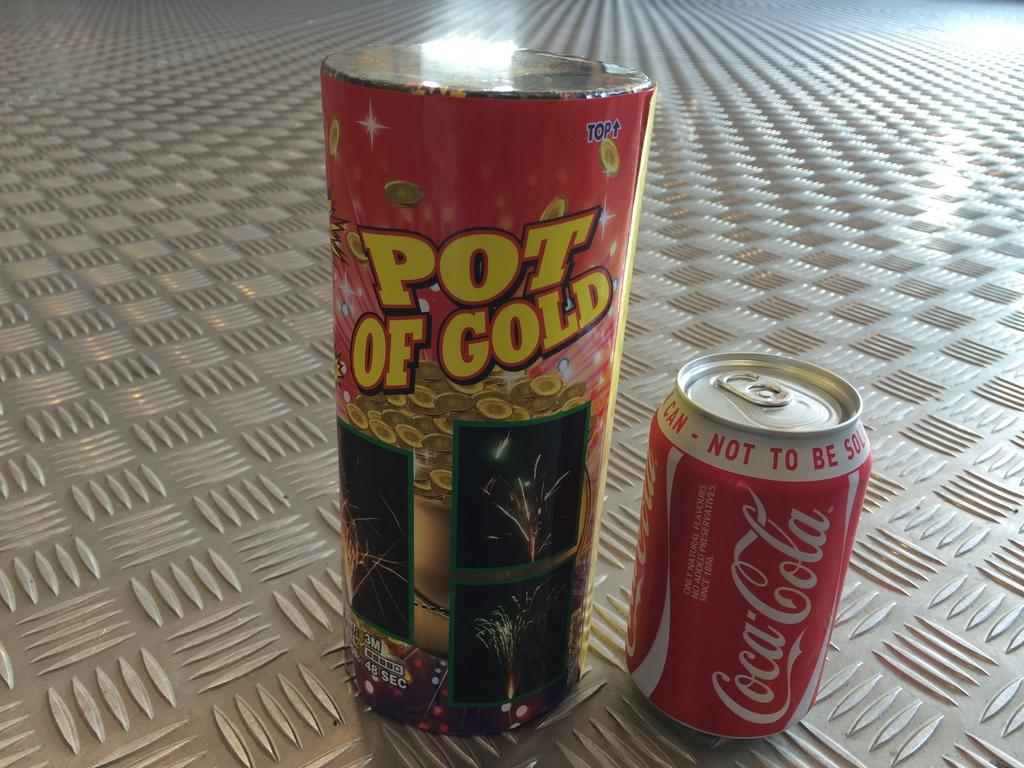<image>
Render a clear and concise summary of the photo. A can of Coca-cola sits next to a canister that says "pot of gold". 